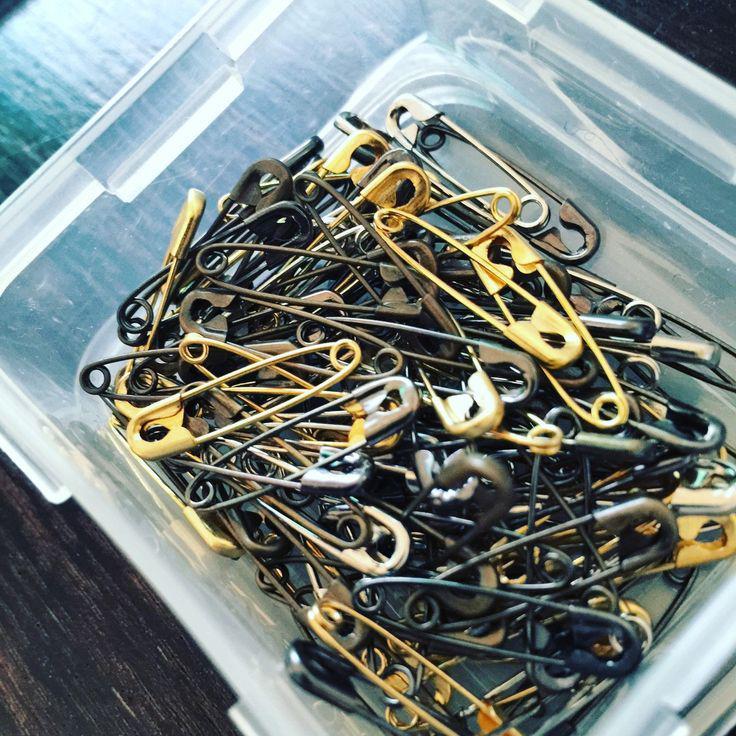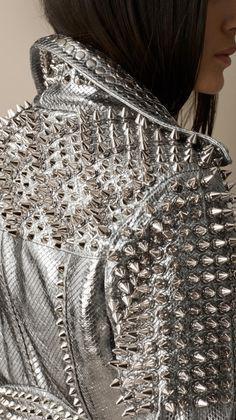The first image is the image on the left, the second image is the image on the right. For the images displayed, is the sentence "At least one image in the pari has both gold and silver colored safety pins." factually correct? Answer yes or no. Yes. The first image is the image on the left, the second image is the image on the right. For the images displayed, is the sentence "In one picture the safety pins are in a pile on top of each other." factually correct? Answer yes or no. Yes. 